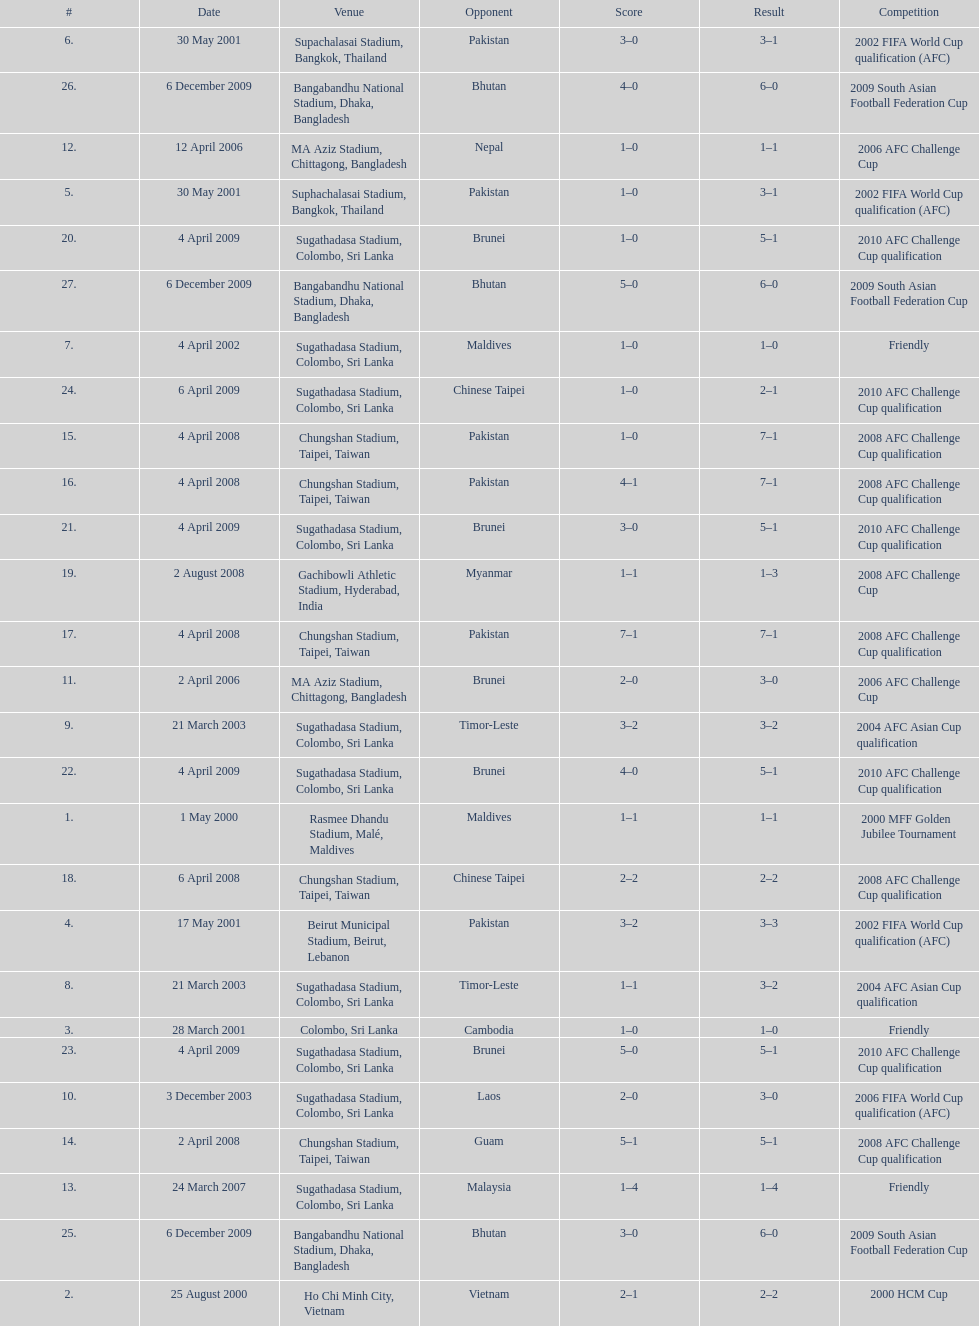What was the next venue after colombo, sri lanka on march 28? Beirut Municipal Stadium, Beirut, Lebanon. Can you parse all the data within this table? {'header': ['#', 'Date', 'Venue', 'Opponent', 'Score', 'Result', 'Competition'], 'rows': [['6.', '30 May 2001', 'Supachalasai Stadium, Bangkok, Thailand', 'Pakistan', '3–0', '3–1', '2002 FIFA World Cup qualification (AFC)'], ['26.', '6 December 2009', 'Bangabandhu National Stadium, Dhaka, Bangladesh', 'Bhutan', '4–0', '6–0', '2009 South Asian Football Federation Cup'], ['12.', '12 April 2006', 'MA Aziz Stadium, Chittagong, Bangladesh', 'Nepal', '1–0', '1–1', '2006 AFC Challenge Cup'], ['5.', '30 May 2001', 'Suphachalasai Stadium, Bangkok, Thailand', 'Pakistan', '1–0', '3–1', '2002 FIFA World Cup qualification (AFC)'], ['20.', '4 April 2009', 'Sugathadasa Stadium, Colombo, Sri Lanka', 'Brunei', '1–0', '5–1', '2010 AFC Challenge Cup qualification'], ['27.', '6 December 2009', 'Bangabandhu National Stadium, Dhaka, Bangladesh', 'Bhutan', '5–0', '6–0', '2009 South Asian Football Federation Cup'], ['7.', '4 April 2002', 'Sugathadasa Stadium, Colombo, Sri Lanka', 'Maldives', '1–0', '1–0', 'Friendly'], ['24.', '6 April 2009', 'Sugathadasa Stadium, Colombo, Sri Lanka', 'Chinese Taipei', '1–0', '2–1', '2010 AFC Challenge Cup qualification'], ['15.', '4 April 2008', 'Chungshan Stadium, Taipei, Taiwan', 'Pakistan', '1–0', '7–1', '2008 AFC Challenge Cup qualification'], ['16.', '4 April 2008', 'Chungshan Stadium, Taipei, Taiwan', 'Pakistan', '4–1', '7–1', '2008 AFC Challenge Cup qualification'], ['21.', '4 April 2009', 'Sugathadasa Stadium, Colombo, Sri Lanka', 'Brunei', '3–0', '5–1', '2010 AFC Challenge Cup qualification'], ['19.', '2 August 2008', 'Gachibowli Athletic Stadium, Hyderabad, India', 'Myanmar', '1–1', '1–3', '2008 AFC Challenge Cup'], ['17.', '4 April 2008', 'Chungshan Stadium, Taipei, Taiwan', 'Pakistan', '7–1', '7–1', '2008 AFC Challenge Cup qualification'], ['11.', '2 April 2006', 'MA Aziz Stadium, Chittagong, Bangladesh', 'Brunei', '2–0', '3–0', '2006 AFC Challenge Cup'], ['9.', '21 March 2003', 'Sugathadasa Stadium, Colombo, Sri Lanka', 'Timor-Leste', '3–2', '3–2', '2004 AFC Asian Cup qualification'], ['22.', '4 April 2009', 'Sugathadasa Stadium, Colombo, Sri Lanka', 'Brunei', '4–0', '5–1', '2010 AFC Challenge Cup qualification'], ['1.', '1 May 2000', 'Rasmee Dhandu Stadium, Malé, Maldives', 'Maldives', '1–1', '1–1', '2000 MFF Golden Jubilee Tournament'], ['18.', '6 April 2008', 'Chungshan Stadium, Taipei, Taiwan', 'Chinese Taipei', '2–2', '2–2', '2008 AFC Challenge Cup qualification'], ['4.', '17 May 2001', 'Beirut Municipal Stadium, Beirut, Lebanon', 'Pakistan', '3–2', '3–3', '2002 FIFA World Cup qualification (AFC)'], ['8.', '21 March 2003', 'Sugathadasa Stadium, Colombo, Sri Lanka', 'Timor-Leste', '1–1', '3–2', '2004 AFC Asian Cup qualification'], ['3.', '28 March 2001', 'Colombo, Sri Lanka', 'Cambodia', '1–0', '1–0', 'Friendly'], ['23.', '4 April 2009', 'Sugathadasa Stadium, Colombo, Sri Lanka', 'Brunei', '5–0', '5–1', '2010 AFC Challenge Cup qualification'], ['10.', '3 December 2003', 'Sugathadasa Stadium, Colombo, Sri Lanka', 'Laos', '2–0', '3–0', '2006 FIFA World Cup qualification (AFC)'], ['14.', '2 April 2008', 'Chungshan Stadium, Taipei, Taiwan', 'Guam', '5–1', '5–1', '2008 AFC Challenge Cup qualification'], ['13.', '24 March 2007', 'Sugathadasa Stadium, Colombo, Sri Lanka', 'Malaysia', '1–4', '1–4', 'Friendly'], ['25.', '6 December 2009', 'Bangabandhu National Stadium, Dhaka, Bangladesh', 'Bhutan', '3–0', '6–0', '2009 South Asian Football Federation Cup'], ['2.', '25 August 2000', 'Ho Chi Minh City, Vietnam', 'Vietnam', '2–1', '2–2', '2000 HCM Cup']]} 